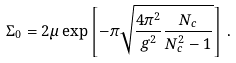Convert formula to latex. <formula><loc_0><loc_0><loc_500><loc_500>\Sigma _ { 0 } = 2 \mu \exp \left [ - \pi \sqrt { \frac { 4 \pi ^ { 2 } } { g ^ { 2 } } \frac { N _ { c } } { N _ { c } ^ { 2 } - 1 } } \right ] \, .</formula> 